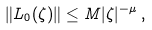<formula> <loc_0><loc_0><loc_500><loc_500>\| { L } _ { 0 } ( \zeta ) \| \leq M | \zeta | ^ { - \mu } \, ,</formula> 